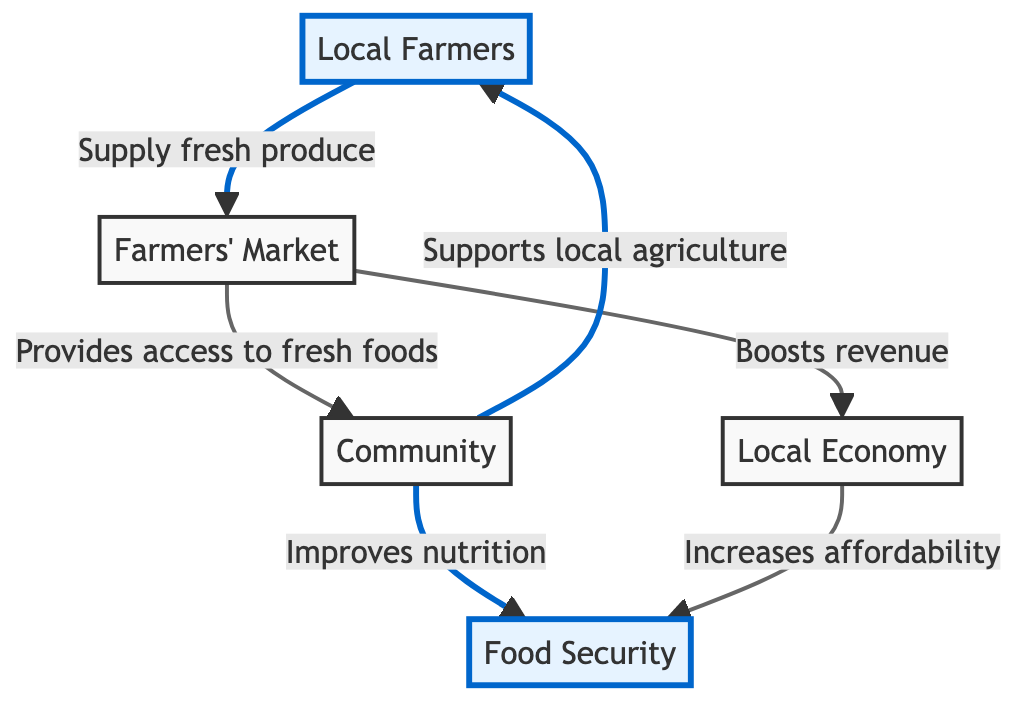What is the starting point of this food chain? The starting point of this food chain is "Local Farmers," which is indicated as the first node in the diagram.
Answer: Local Farmers How many nodes are present in the diagram? The diagram contains 5 nodes: Local Farmers, Farmers' Market, Community, Food Security, and Local Economy.
Answer: 5 What is the relationship between Farmers' Market and Community? The relationship is that the Farmers' Market "Provides access to fresh foods" to the Community, which is a direct connection in the diagram.
Answer: Provides access to fresh foods What node is affected by the action "Improves nutrition"? The action "Improves nutrition" affects the node "Food Security," as indicated in the flow from Community to Food Security.
Answer: Food Security How does Local Economy impact Food Security? The Local Economy impacts Food Security by "Increases affordability," which connects the Local Economy to Food Security in the flow of the diagram.
Answer: Increases affordability Which node provides fresh produce? The node that provides fresh produce is "Local Farmers," which is indicated in the diagram as supplying to the Farmers' Market.
Answer: Local Farmers What effect does the Farmers' Market have on Local Economy? The effect is that the Farmers' Market "Boosts revenue," which relates the Farmers' Market directly to the Local Economy in the flow.
Answer: Boosts revenue What node supports local agriculture as per the diagram? The node that supports local agriculture is "Community," as indicated by the direct flow from Community to Local Farmers.
Answer: Community Which two nodes are connected by an arrow from Community? The two nodes connected by an arrow from Community are "Food Security" and "Local Farmers." The flow indicates Community impacts both nodes.
Answer: Food Security and Local Farmers 